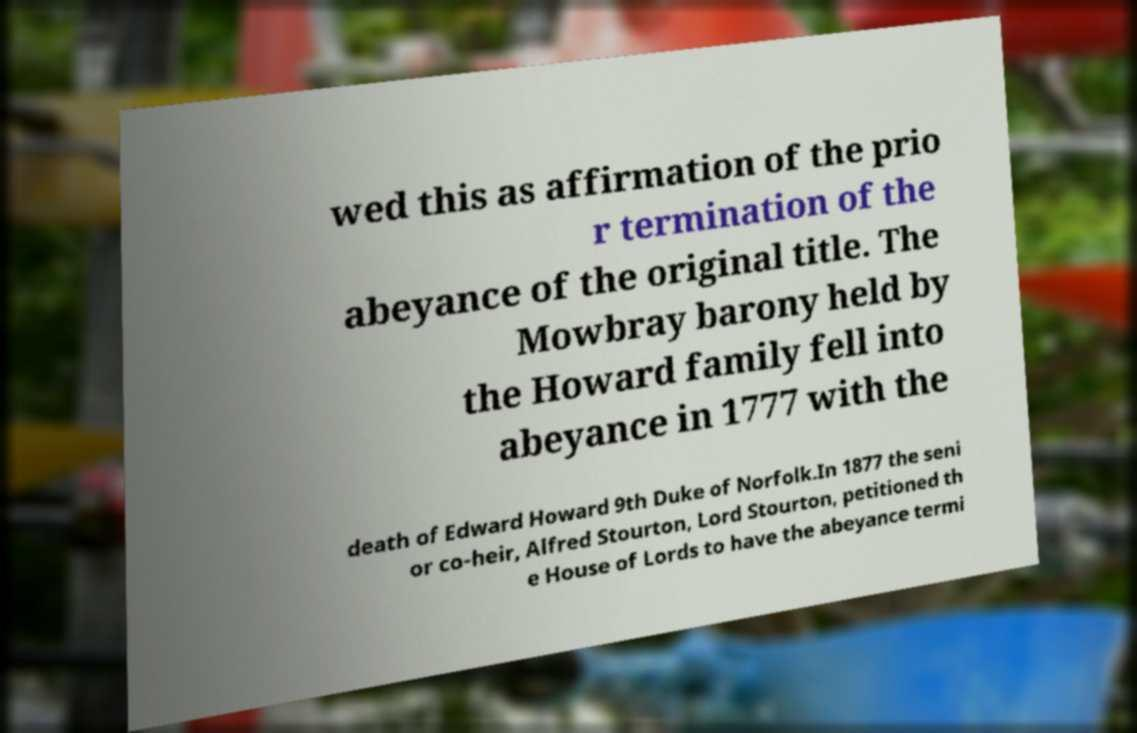I need the written content from this picture converted into text. Can you do that? wed this as affirmation of the prio r termination of the abeyance of the original title. The Mowbray barony held by the Howard family fell into abeyance in 1777 with the death of Edward Howard 9th Duke of Norfolk.In 1877 the seni or co-heir, Alfred Stourton, Lord Stourton, petitioned th e House of Lords to have the abeyance termi 